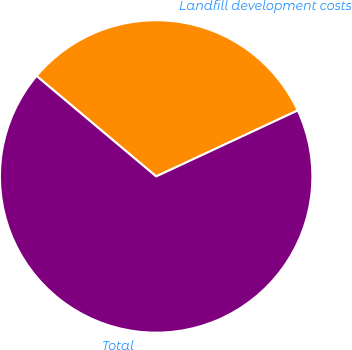<chart> <loc_0><loc_0><loc_500><loc_500><pie_chart><fcel>Landfill development costs<fcel>Total<nl><fcel>31.94%<fcel>68.06%<nl></chart> 